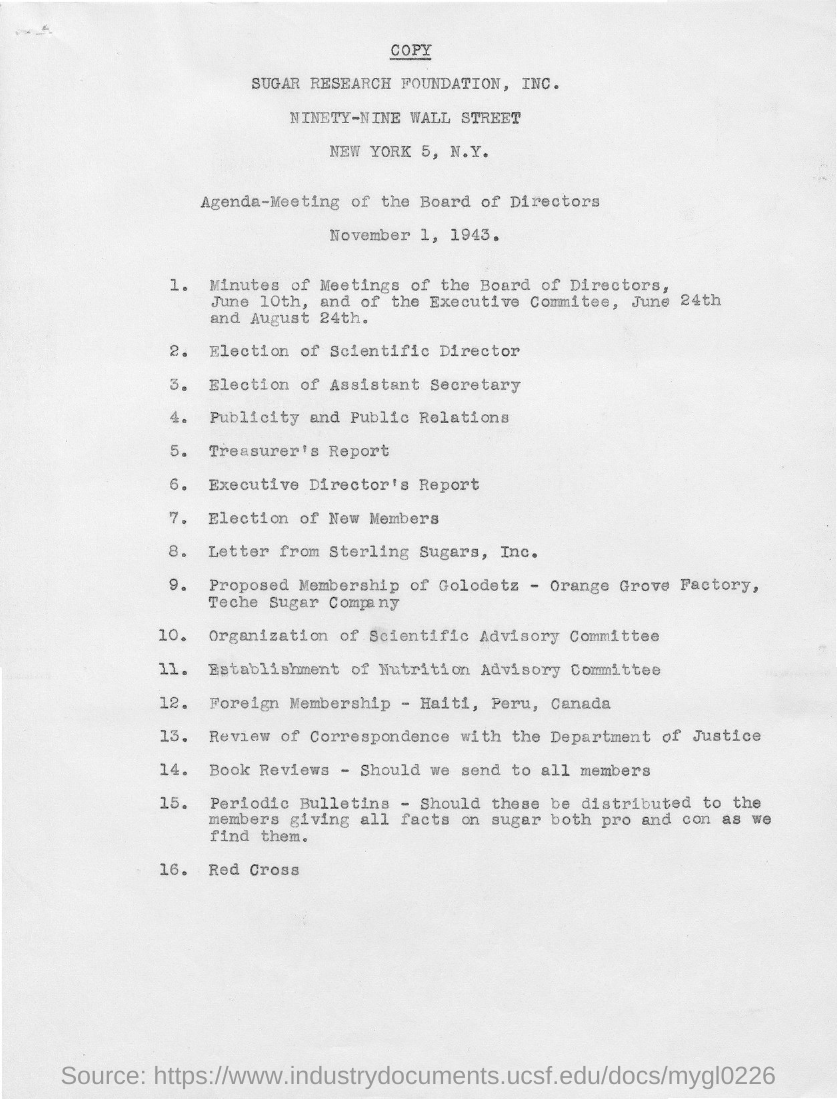It is the agenda for what? The document is an agenda for a meeting of the Board of Directors of the Sugar Research Foundation, Inc., dated November 1, 1943. This meeting was scheduled to cover numerous topics including elections of key personnel, financial reports, and matters concerning memberships and scientific committees. 